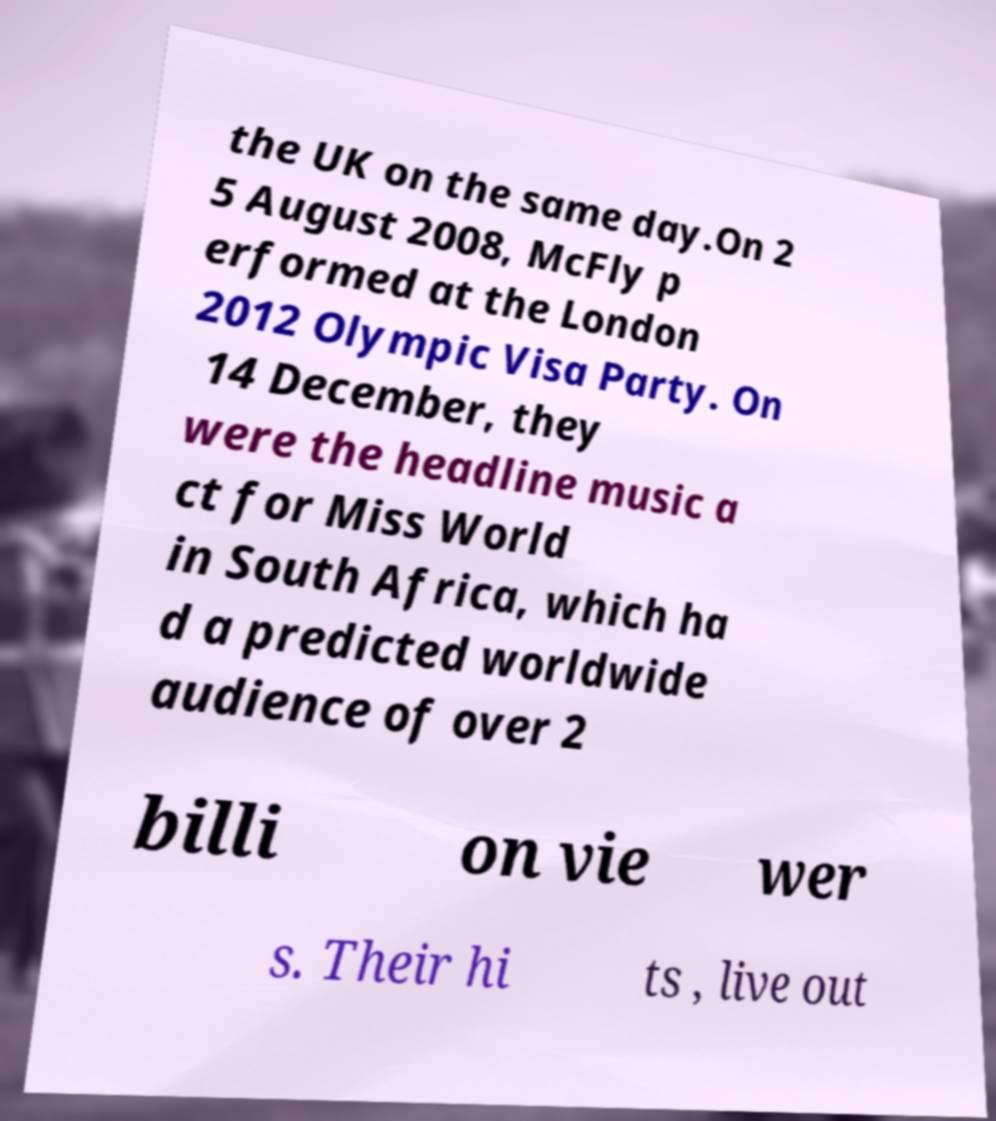Could you assist in decoding the text presented in this image and type it out clearly? the UK on the same day.On 2 5 August 2008, McFly p erformed at the London 2012 Olympic Visa Party. On 14 December, they were the headline music a ct for Miss World in South Africa, which ha d a predicted worldwide audience of over 2 billi on vie wer s. Their hi ts , live out 